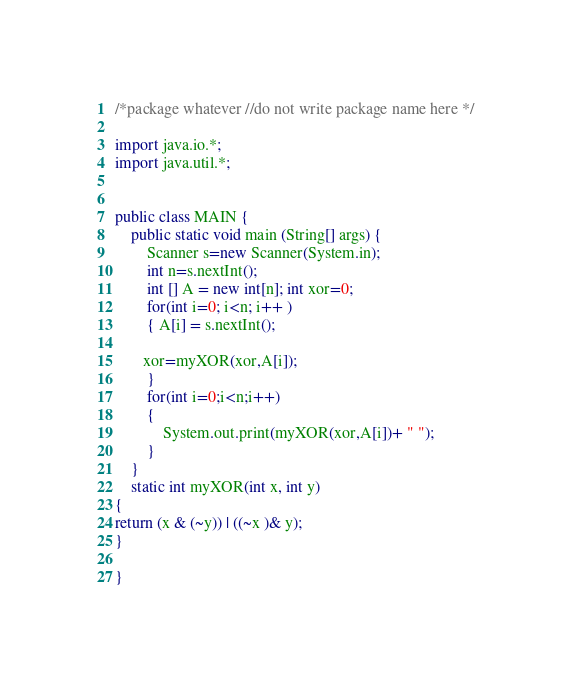Convert code to text. <code><loc_0><loc_0><loc_500><loc_500><_Java_>/*package whatever //do not write package name here */

import java.io.*;
import java.util.*;


public class MAIN {
	public static void main (String[] args) {
	    Scanner s=new Scanner(System.in);
	    int n=s.nextInt();
        int [] A = new int[n]; int xor=0;
        for(int i=0; i<n; i++ ) 
        { A[i] = s.nextInt();
         
       xor=myXOR(xor,A[i]);
        }
        for(int i=0;i<n;i++)
        {
            System.out.print(myXOR(xor,A[i])+ " ");
        }
	}
	static int myXOR(int x, int y) 
{ 
return (x & (~y)) | ((~x )& y); 
} 
  
}</code> 